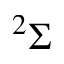Convert formula to latex. <formula><loc_0><loc_0><loc_500><loc_500>^ { 2 } \Sigma</formula> 